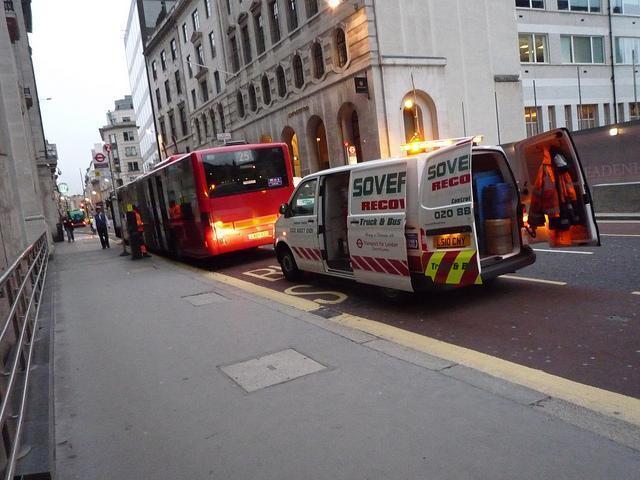Why is the red vehicle stopped here?
Answer the question by selecting the correct answer among the 4 following choices.
Options: Protest, sales trick, boarding passengers, accident. Boarding passengers. 